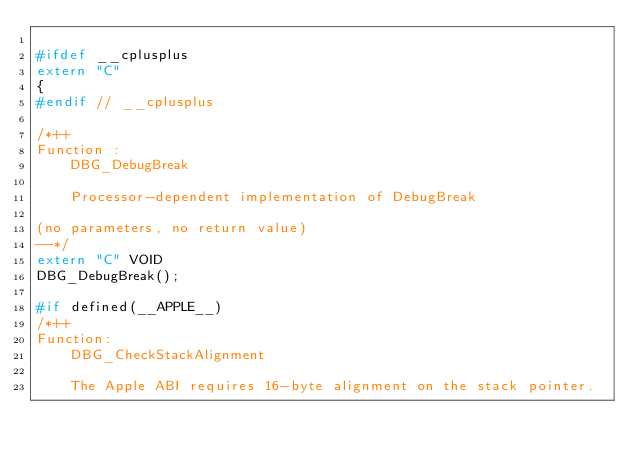<code> <loc_0><loc_0><loc_500><loc_500><_C_>
#ifdef __cplusplus
extern "C"
{
#endif // __cplusplus

/*++
Function :
    DBG_DebugBreak

    Processor-dependent implementation of DebugBreak

(no parameters, no return value)
--*/
extern "C" VOID
DBG_DebugBreak();

#if defined(__APPLE__)
/*++
Function:
    DBG_CheckStackAlignment

    The Apple ABI requires 16-byte alignment on the stack pointer.</code> 